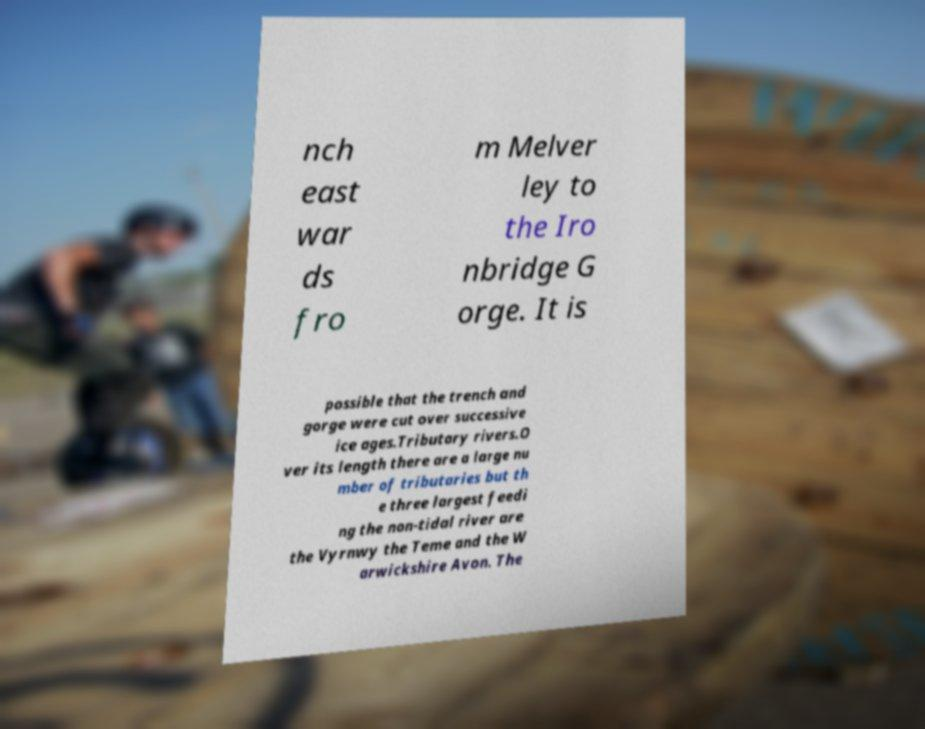I need the written content from this picture converted into text. Can you do that? nch east war ds fro m Melver ley to the Iro nbridge G orge. It is possible that the trench and gorge were cut over successive ice ages.Tributary rivers.O ver its length there are a large nu mber of tributaries but th e three largest feedi ng the non-tidal river are the Vyrnwy the Teme and the W arwickshire Avon. The 